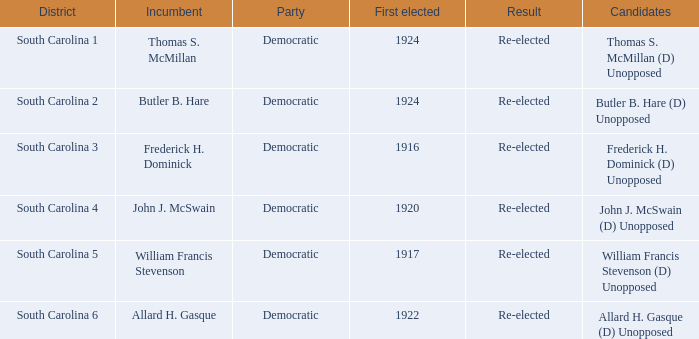Give me the full table as a dictionary. {'header': ['District', 'Incumbent', 'Party', 'First elected', 'Result', 'Candidates'], 'rows': [['South Carolina 1', 'Thomas S. McMillan', 'Democratic', '1924', 'Re-elected', 'Thomas S. McMillan (D) Unopposed'], ['South Carolina 2', 'Butler B. Hare', 'Democratic', '1924', 'Re-elected', 'Butler B. Hare (D) Unopposed'], ['South Carolina 3', 'Frederick H. Dominick', 'Democratic', '1916', 'Re-elected', 'Frederick H. Dominick (D) Unopposed'], ['South Carolina 4', 'John J. McSwain', 'Democratic', '1920', 'Re-elected', 'John J. McSwain (D) Unopposed'], ['South Carolina 5', 'William Francis Stevenson', 'Democratic', '1917', 'Re-elected', 'William Francis Stevenson (D) Unopposed'], ['South Carolina 6', 'Allard H. Gasque', 'Democratic', '1922', 'Re-elected', 'Allard H. Gasque (D) Unopposed']]} What is the result for south carolina 4? Re-elected. 